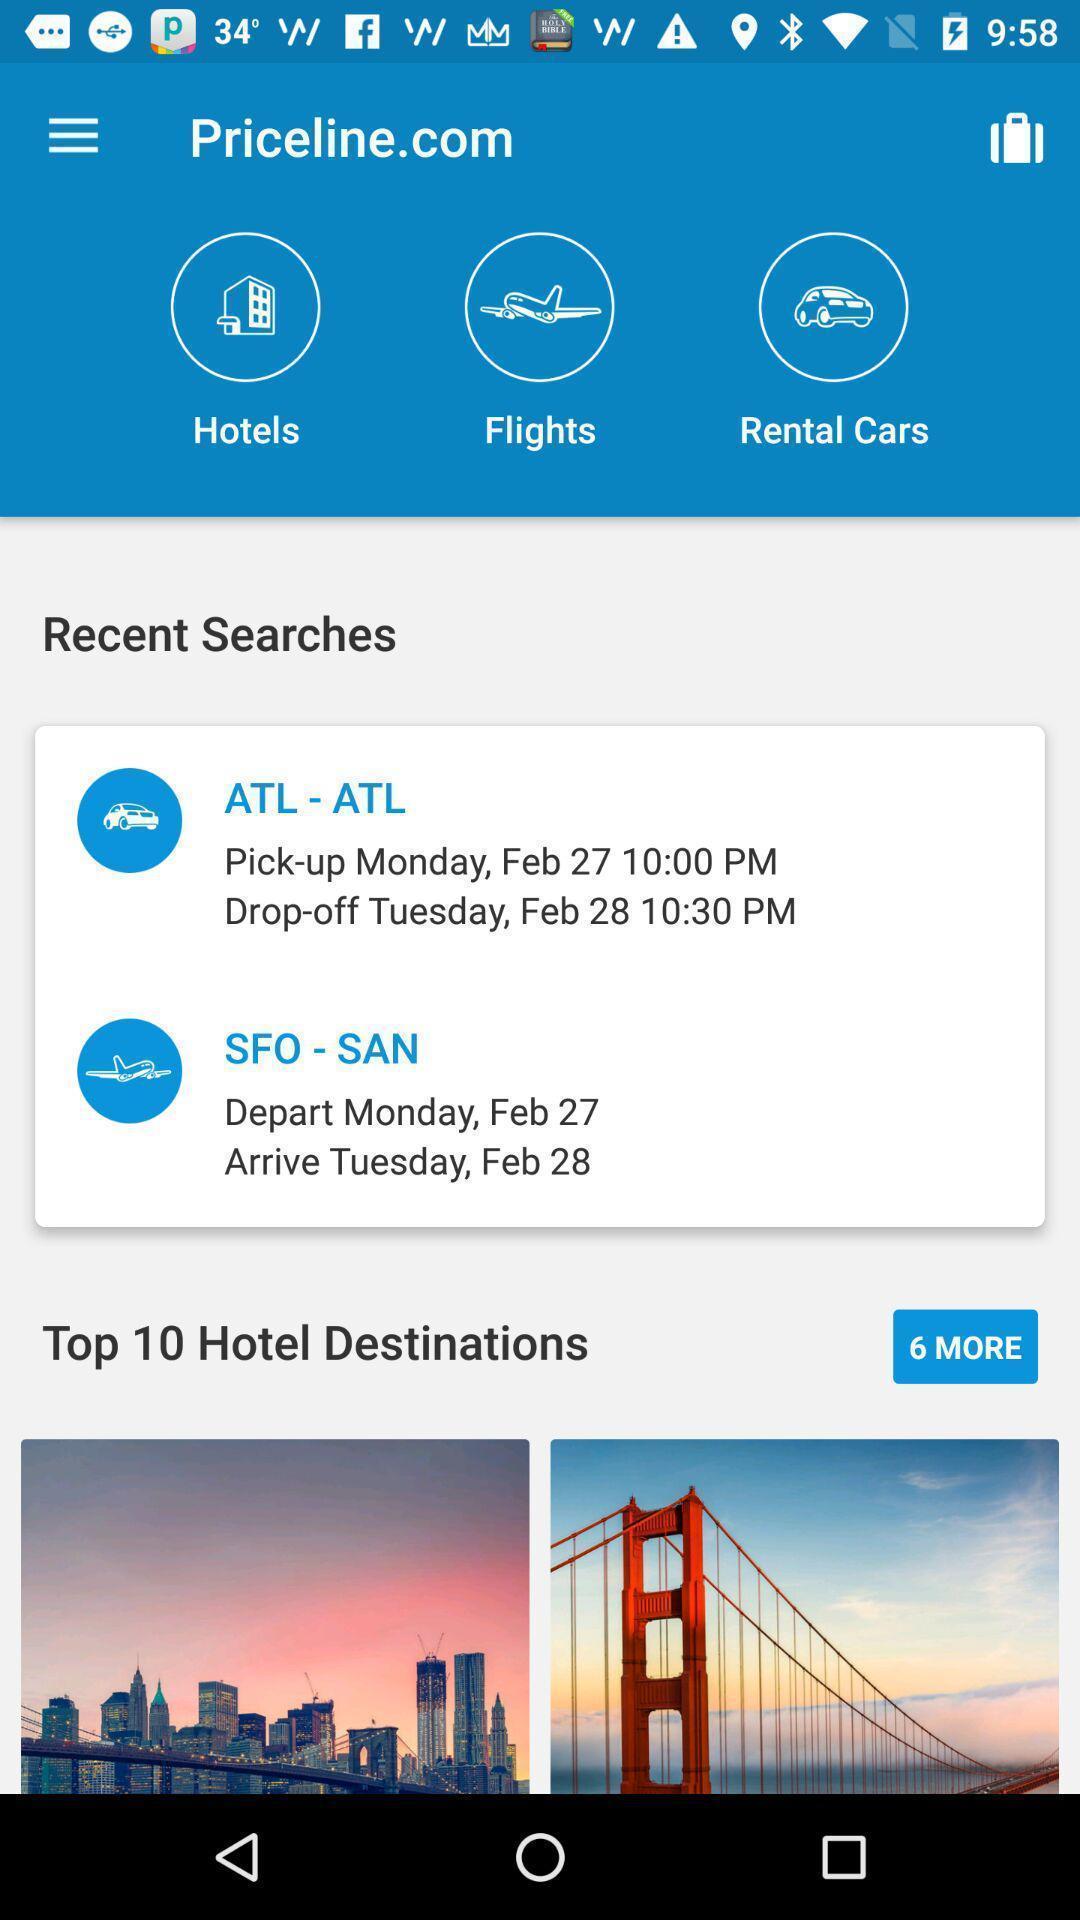Provide a detailed account of this screenshot. Recent searches of travelling app. 